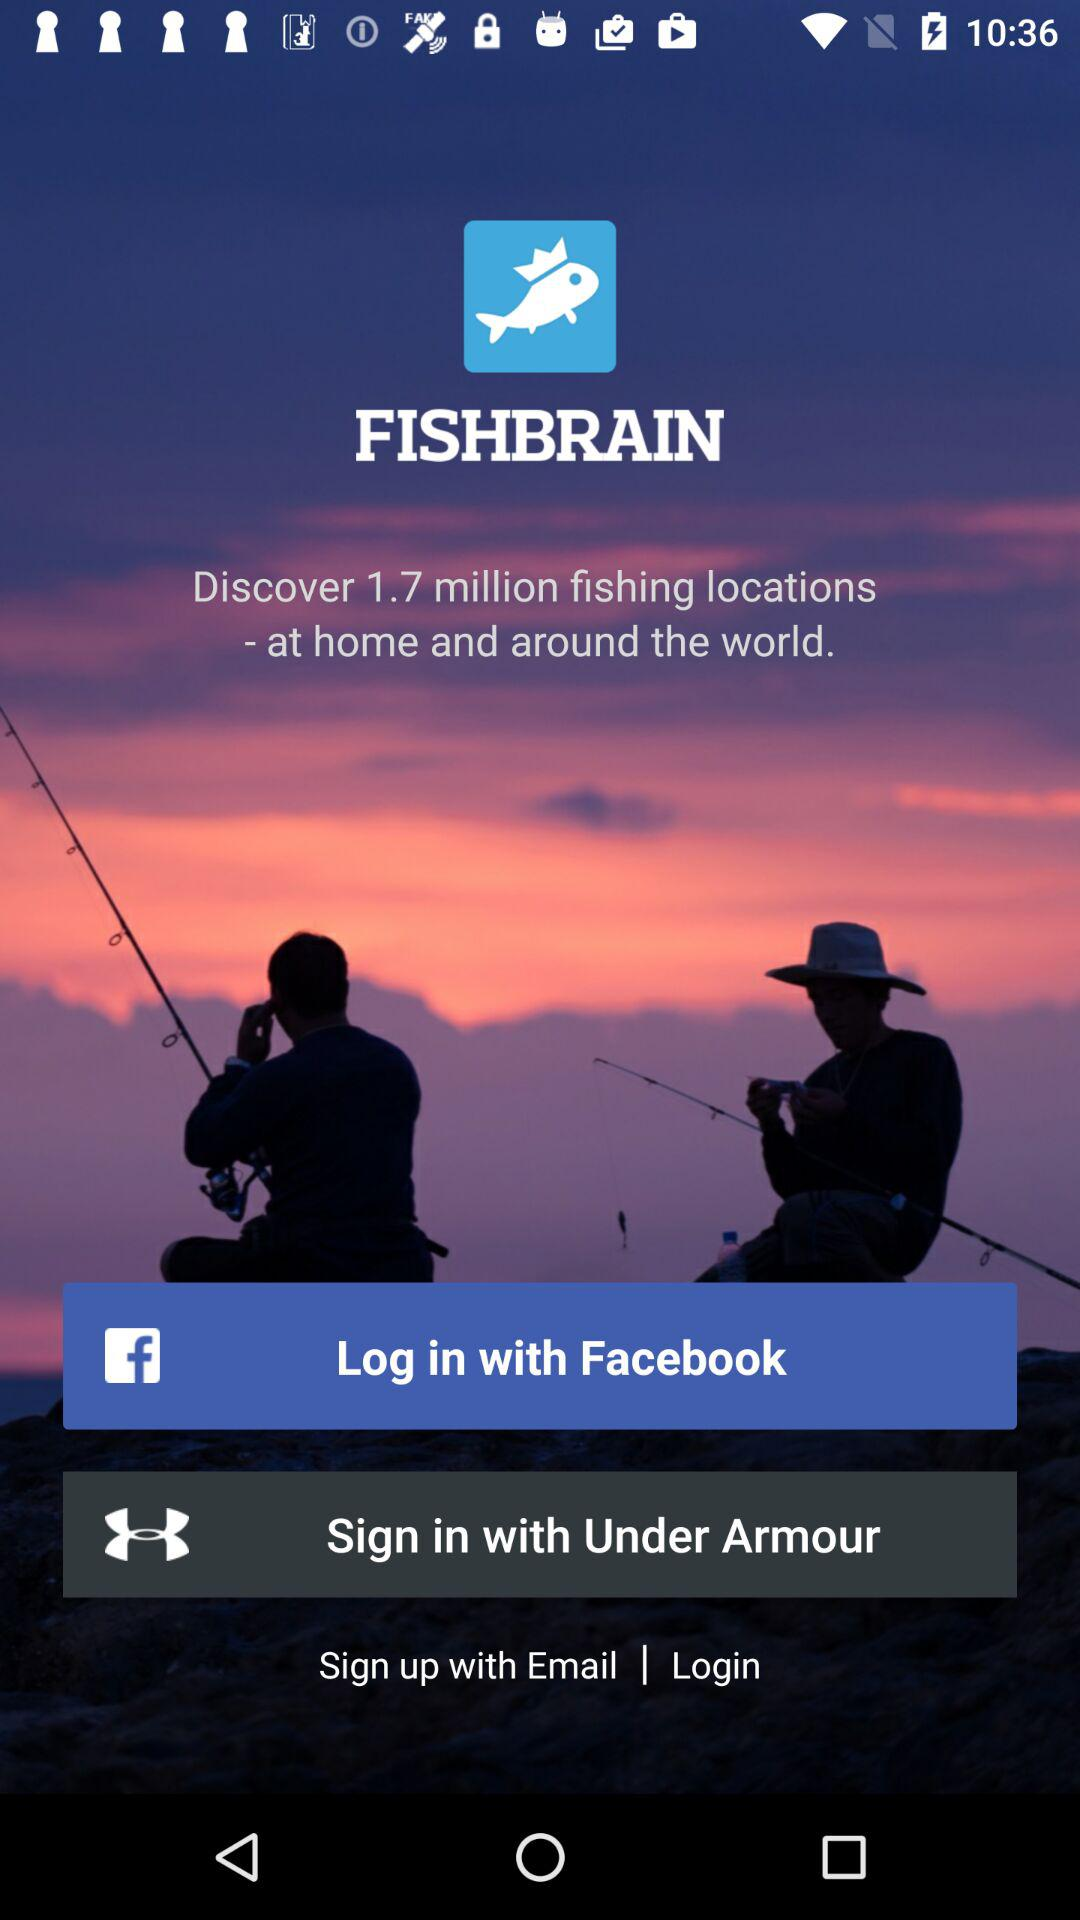Through which application can we sign in? You can sign in through "Facebook" and "Under Armour". 